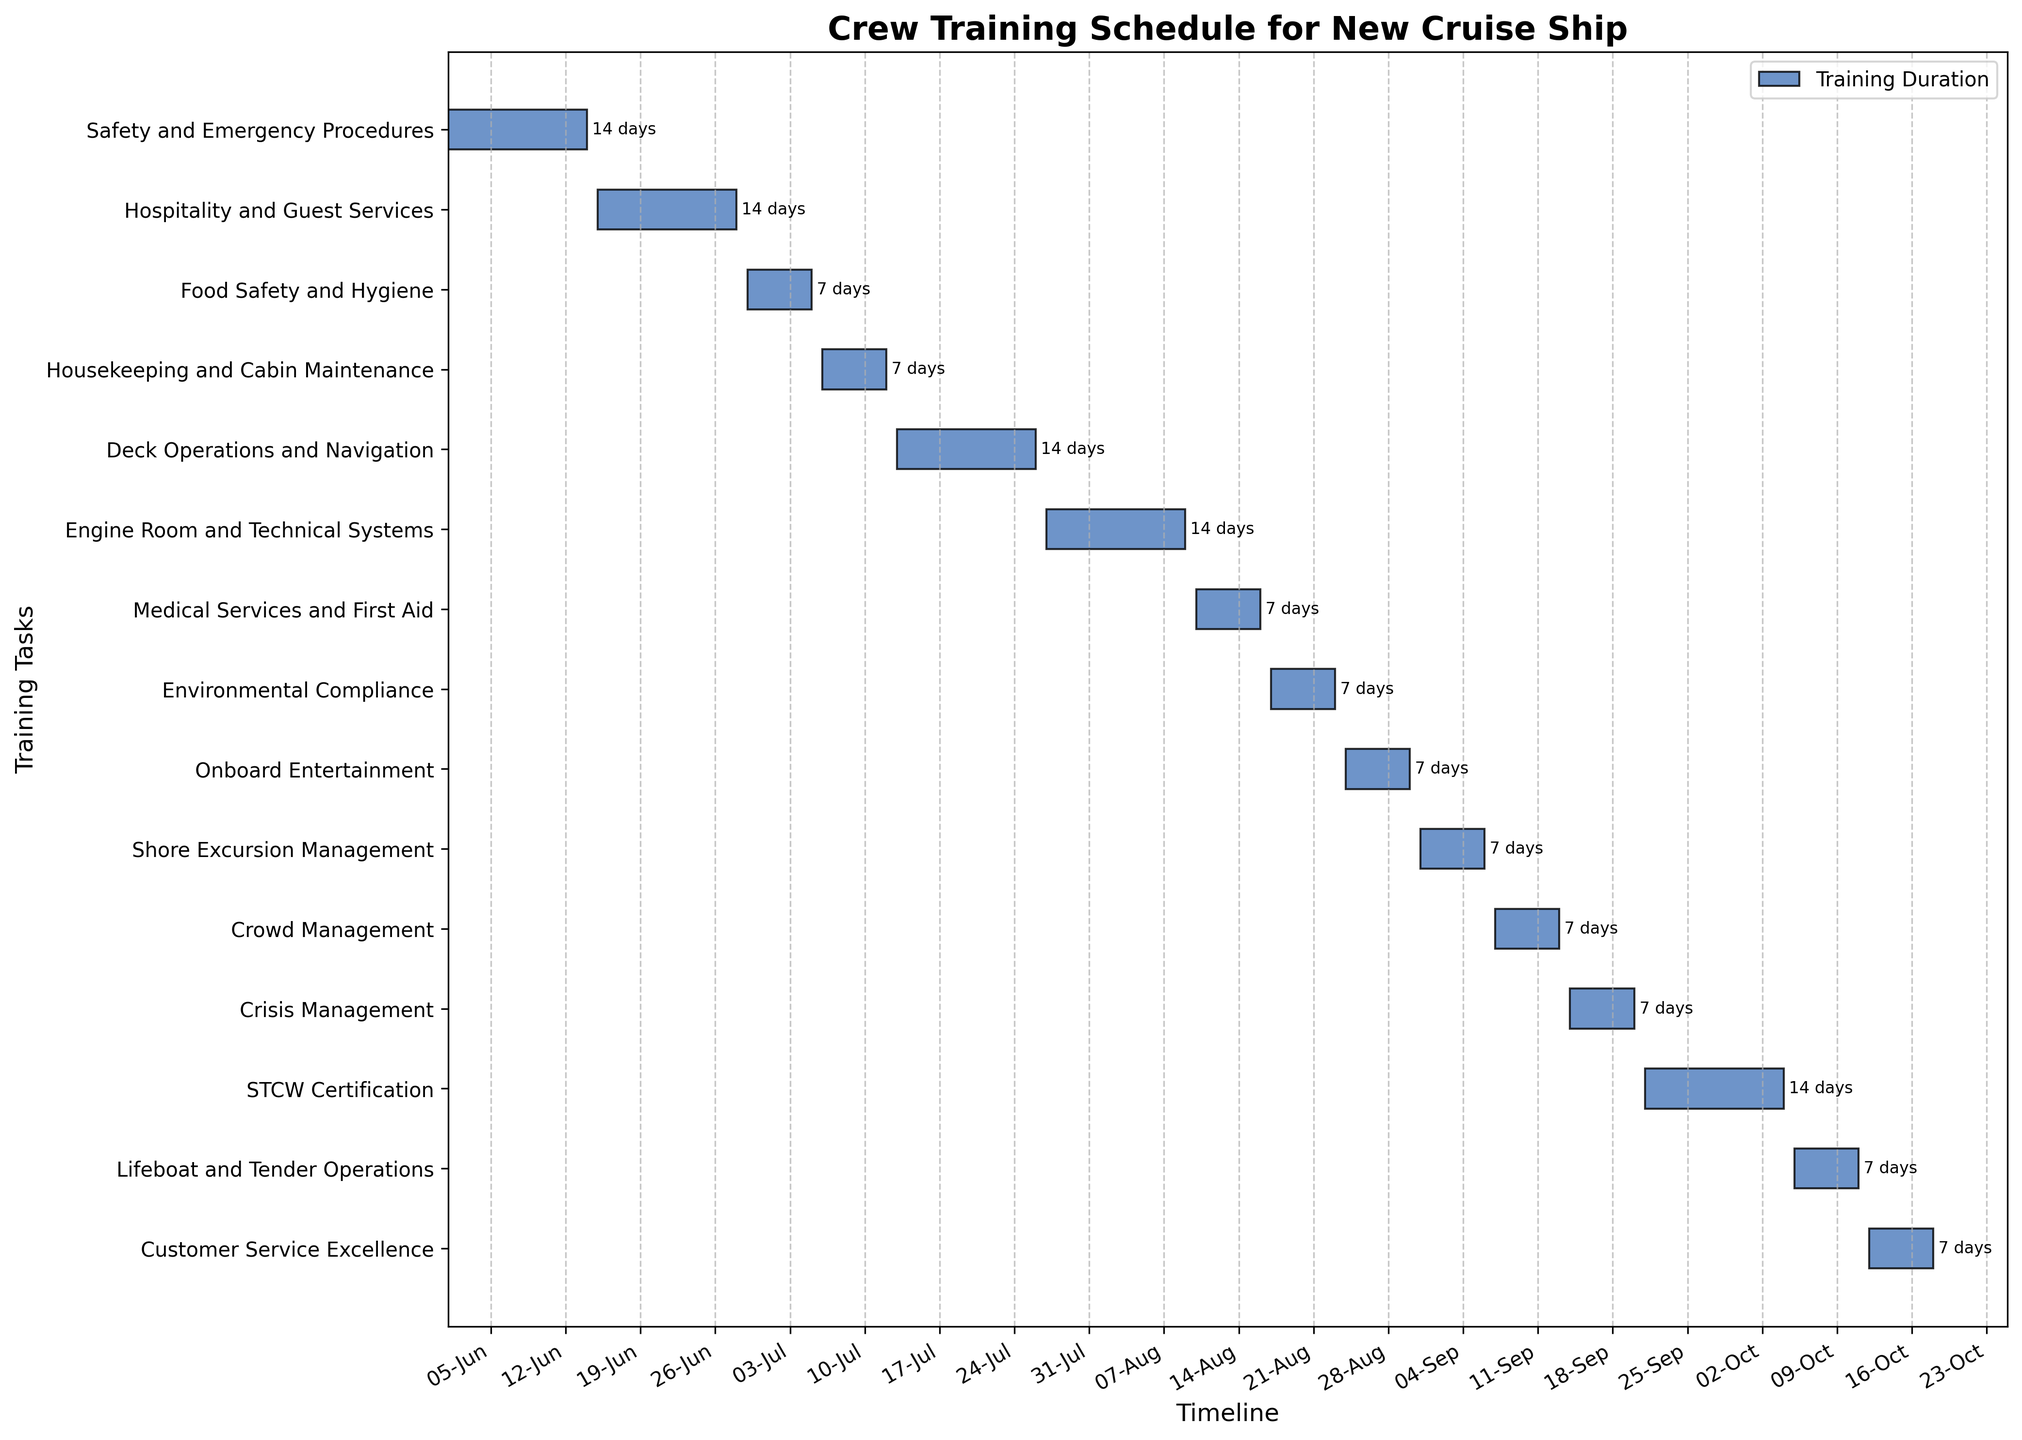What is the title of the chart? The title of the chart is generally located at the top of the figure and is used to convey the main topic or purpose of the chart. In this case, the title is "Crew Training Schedule for New Cruise Ship."
Answer: Crew Training Schedule for New Cruise Ship What is the duration of the Safety and Emergency Procedures training? Look at the bar corresponding to "Safety and Emergency Procedures" on the y-axis and check the length of the bar on the x-axis. The duration text label next to this bar shows the number of days.
Answer: 14 days How many training tasks have a duration of 7 days? Identify bars that correspond to tasks with a duration text label of "7 days" next to them. Count the number of these bars on the chart.
Answer: 8 tasks Which training ends on June 28, 2023? Look at the end dates on the x-axis for each bar and find the one that ends on June 28, 2023. The corresponding task on the y-axis is the answer.
Answer: Hospitality and Guest Services What is the total duration of all training combined? Sum up the duration (in days) of each training task listed on the y-axis. For example, sum of the durations 14, 14, 7, 7, 14, 14, 7, 7, 7, 7, 7, 7, 14, 7, and 7 days respectively.
Answer: 133 days Which training takes place immediately after "Housekeeping and Cabin Maintenance"? Identify the end date of "Housekeeping and Cabin Maintenance," and then find the training that starts the day after this end date. The "Housekeeping and Cabin Maintenance" ends on July 12, 2023, so the next task starting on July 13, 2023 is the answer.
Answer: Deck Operations and Navigation What is the longest single training task? Among all the horizontal bars representing each training task, find the one that stretches farthest on the x-axis. The corresponding task on the y-axis is the longest.
Answer: Several tasks with the duration of 14 days How many training tasks are scheduled to start in the month of August? Count the number of bars whose start date on the x-axis is within the August month. Look for start dates within August 1 to August 31, 2023.
Answer: 4 tasks What training tasks are scheduled concurrently with "Deck Operations and Navigation"? Find the duration of "Deck Operations and Navigation" on the x-axis and any other bars that overlap in duration within this time frame would be scheduled concurrently. In this case, "Deck Operations and Navigation" runs from July 13, 2023, to July 26, 2023. There are no other overlapping tasks.
Answer: None Does "Customer Service Excellence" training start before or after "STCW Certification" ends? Compare the start date of "Customer Service Excellence" with the end date of "STCW Certification." "Customer Service Excellence" starts on October 12, 2023, while "STCW Certification" ends on October 4, 2023, so it starts after the end of "STCW Certification."
Answer: After 